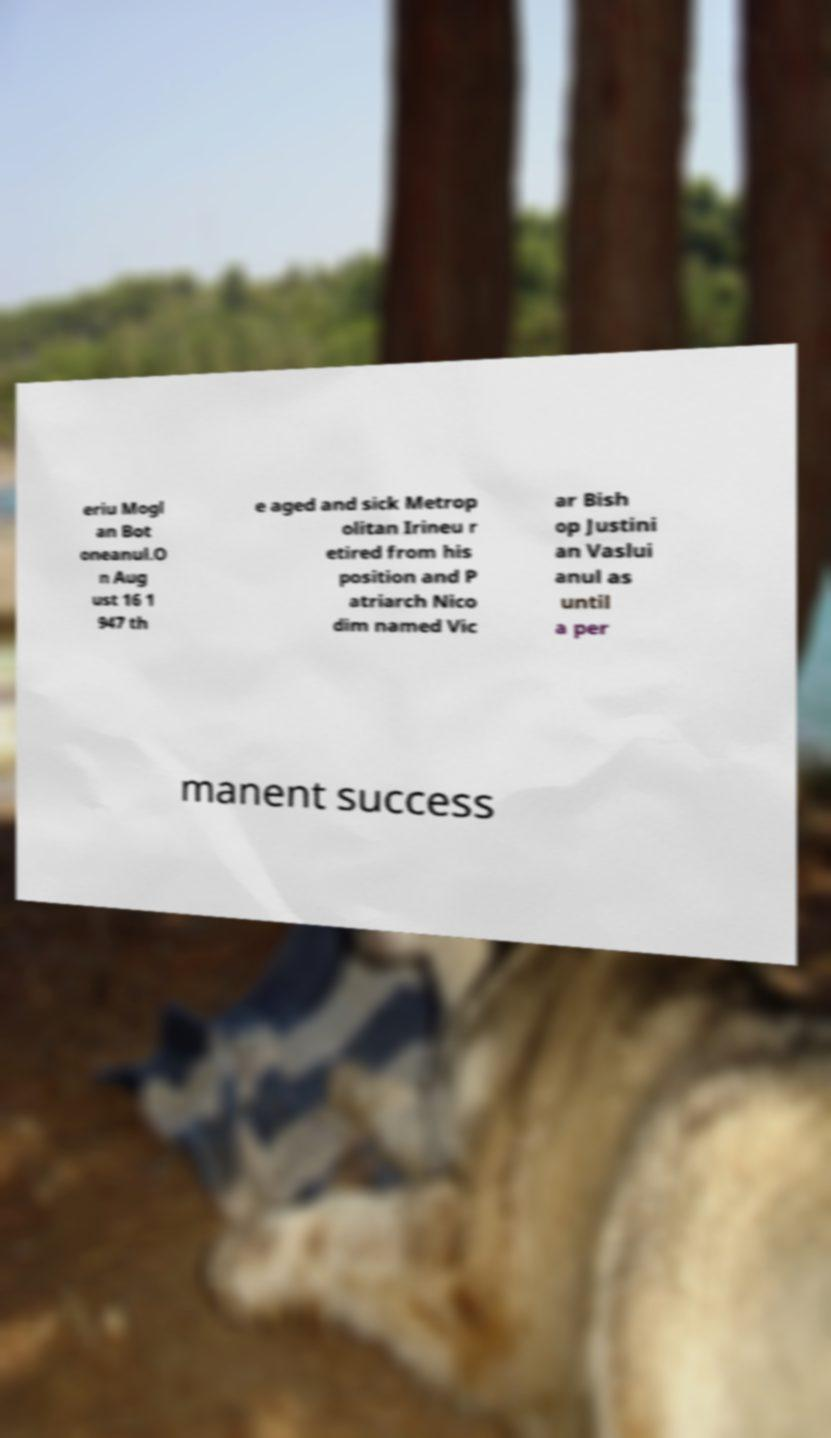Could you assist in decoding the text presented in this image and type it out clearly? eriu Mogl an Bot oneanul.O n Aug ust 16 1 947 th e aged and sick Metrop olitan Irineu r etired from his position and P atriarch Nico dim named Vic ar Bish op Justini an Vaslui anul as until a per manent success 